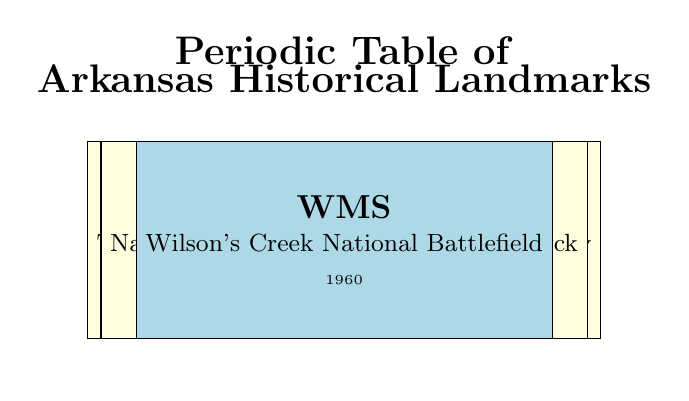What is the significance of Little Rock Central High School? Little Rock Central High School is significant because it was the site of the 1957 Little Rock Nine integration crisis, which symbolized the Civil Rights Movement in the United States.
Answer: Site of the 1957 Little Rock Nine integration crisis How many landmarks were established in Little Rock, Arkansas? From the table, there are four landmarks established in Little Rock, Arkansas: Little Rock Central High School (1927), The Old State House (1833), The William J. Clinton Presidential Library (2004), and National Historic Landmark - Little Rock (2011).
Answer: Four landmarks Which landmark was established most recently? The most recently established landmark in the table is The William J. Clinton Presidential Library, which was established in 2004. This can be identified by comparing the Year Established column for all entries.
Answer: The William J. Clinton Presidential Library What year did the Historic Arkansas Museum open? The Historic Arkansas Museum was established in 1960, as indicated directly in the Year Established column for that landmark.
Answer: 1960 Is the Governor's Mansion significant for its architectural style? Yes, the Governor's Mansion is significant for its architecture as well as its political history, according to the significance description in the table.
Answer: Yes Which landmark has a connection to the Civil War? The Battlefield Park, established in 1956, preserves the site of the 1862 Battle of Pea Ridge, which is a significant Civil War battle. The connective information can be inferred from its significance.
Answer: Battlefield Park Calculate the difference in years between the establishment of The Old State House and The Walton Arts Center. The Old State House was established in 1833, and The Walton Arts Center was established in 1992. The difference in years is 1992 - 1833 = 159 years.
Answer: 159 years Does Cane Hill Historic District feature landmarks from the 19th century? Yes, the Cane Hill Historic District features historic landmarks specifically from the 19th century, as stated in its significance description.
Answer: Yes What is the average year of establishment for the landmarks listed? To find the average year of establishment, sum all the years (1927 + 1833 + 2004 + 1960 + 1956 + 2011 + 1921 + 1950 + 1992 + 1985 + 1960 = 19708) and divide by the number of landmarks (11). Thus, the average year is 19708 / 11 = 1792.545, rounding gives 1793.
Answer: Approximately 1793 